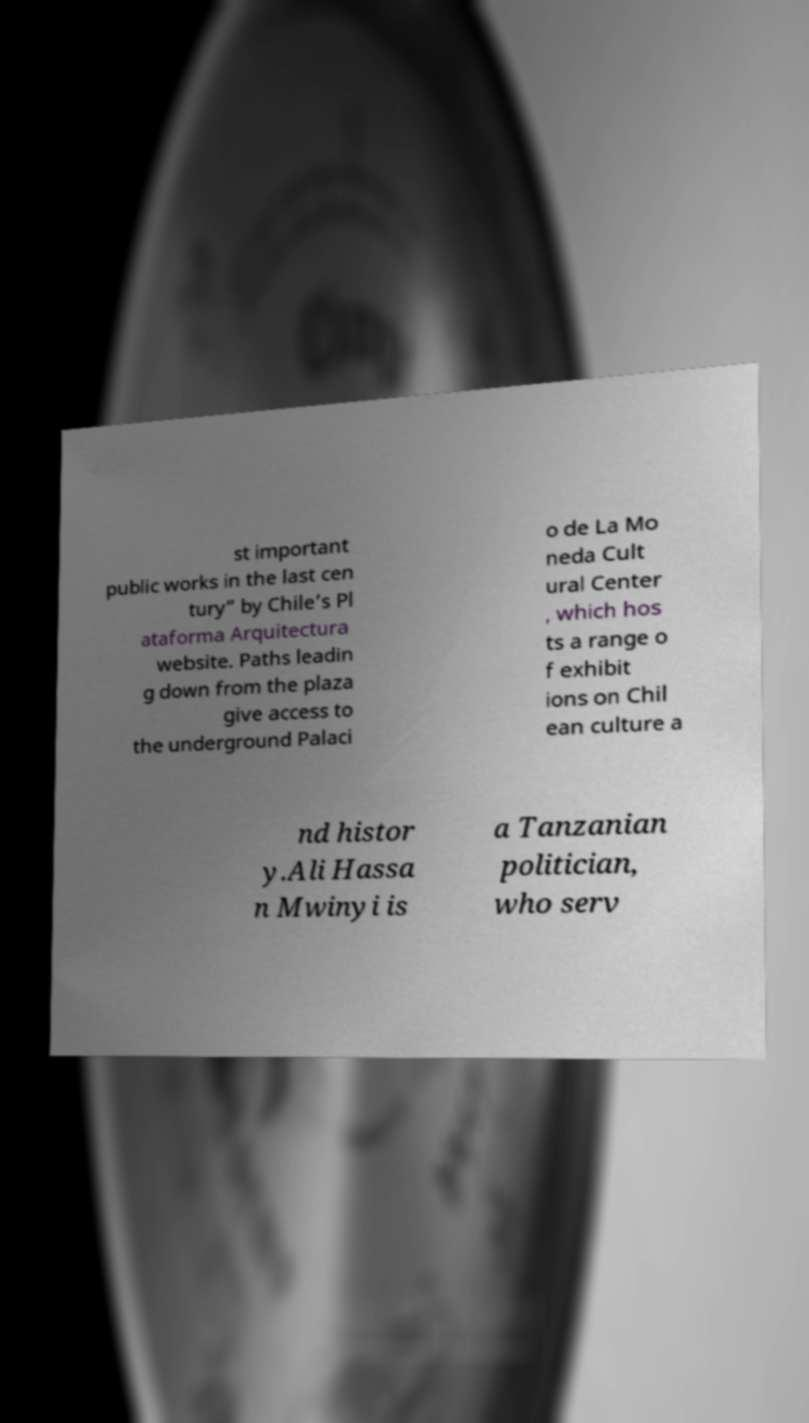Could you extract and type out the text from this image? st important public works in the last cen tury” by Chile’s Pl ataforma Arquitectura website. Paths leadin g down from the plaza give access to the underground Palaci o de La Mo neda Cult ural Center , which hos ts a range o f exhibit ions on Chil ean culture a nd histor y.Ali Hassa n Mwinyi is a Tanzanian politician, who serv 